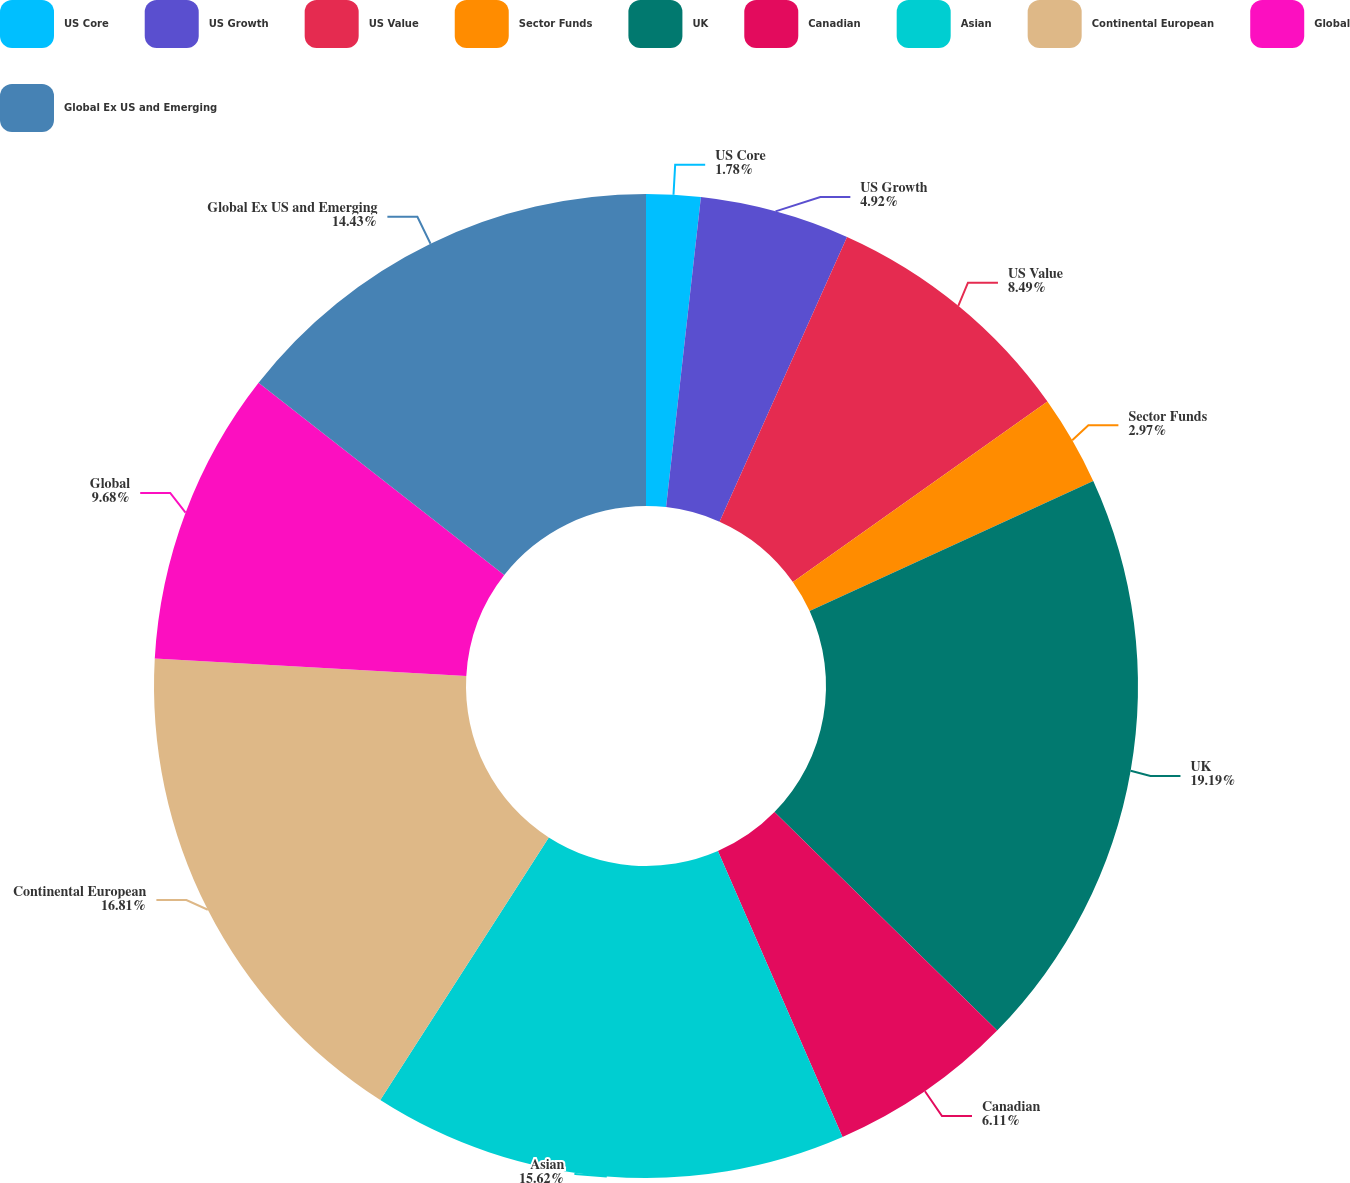<chart> <loc_0><loc_0><loc_500><loc_500><pie_chart><fcel>US Core<fcel>US Growth<fcel>US Value<fcel>Sector Funds<fcel>UK<fcel>Canadian<fcel>Asian<fcel>Continental European<fcel>Global<fcel>Global Ex US and Emerging<nl><fcel>1.78%<fcel>4.92%<fcel>8.49%<fcel>2.97%<fcel>19.19%<fcel>6.11%<fcel>15.62%<fcel>16.81%<fcel>9.68%<fcel>14.43%<nl></chart> 